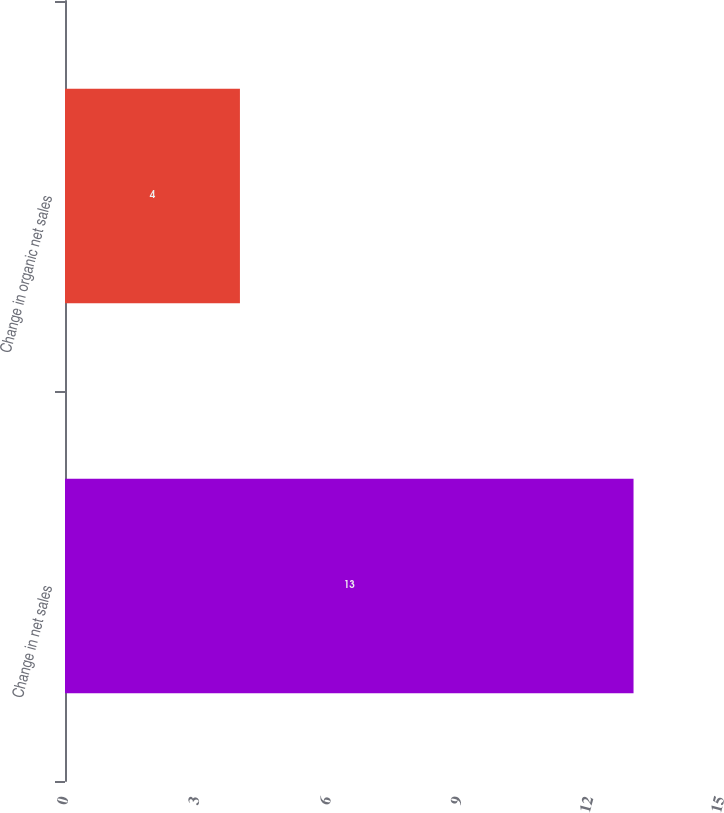<chart> <loc_0><loc_0><loc_500><loc_500><bar_chart><fcel>Change in net sales<fcel>Change in organic net sales<nl><fcel>13<fcel>4<nl></chart> 